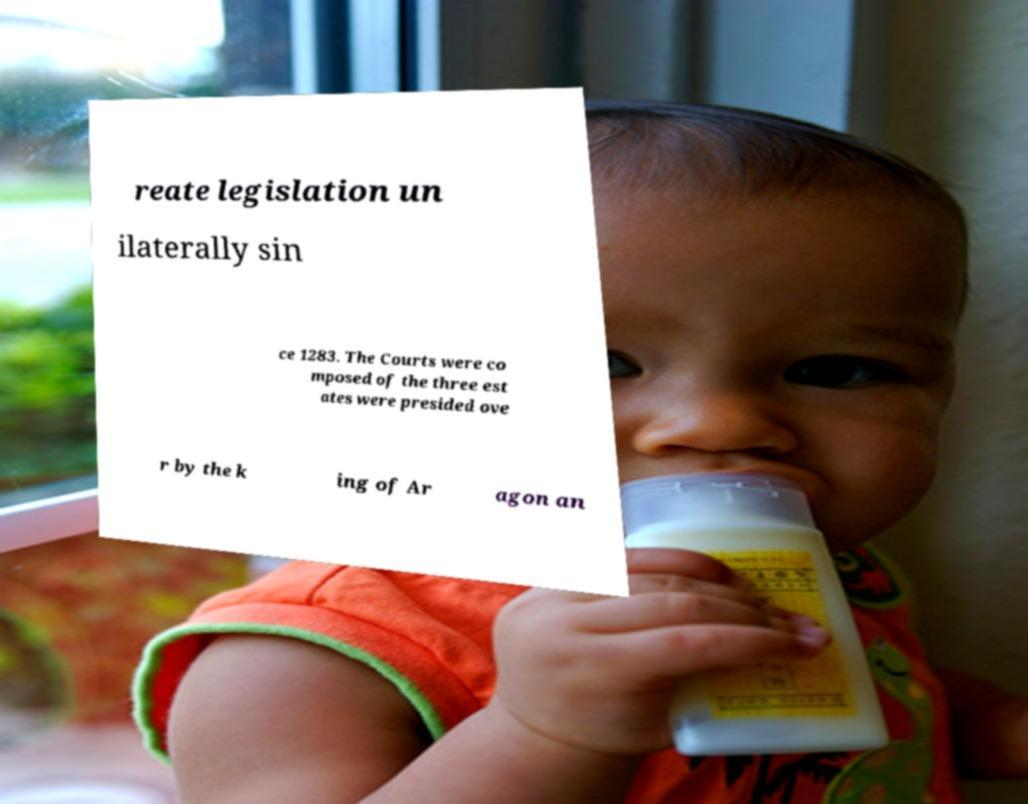I need the written content from this picture converted into text. Can you do that? reate legislation un ilaterally sin ce 1283. The Courts were co mposed of the three est ates were presided ove r by the k ing of Ar agon an 